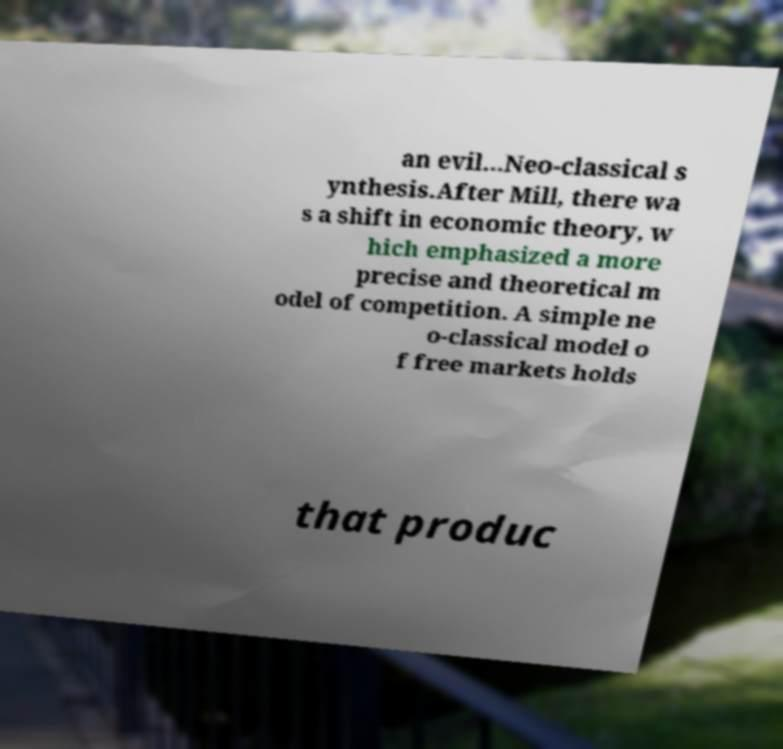What messages or text are displayed in this image? I need them in a readable, typed format. an evil...Neo-classical s ynthesis.After Mill, there wa s a shift in economic theory, w hich emphasized a more precise and theoretical m odel of competition. A simple ne o-classical model o f free markets holds that produc 